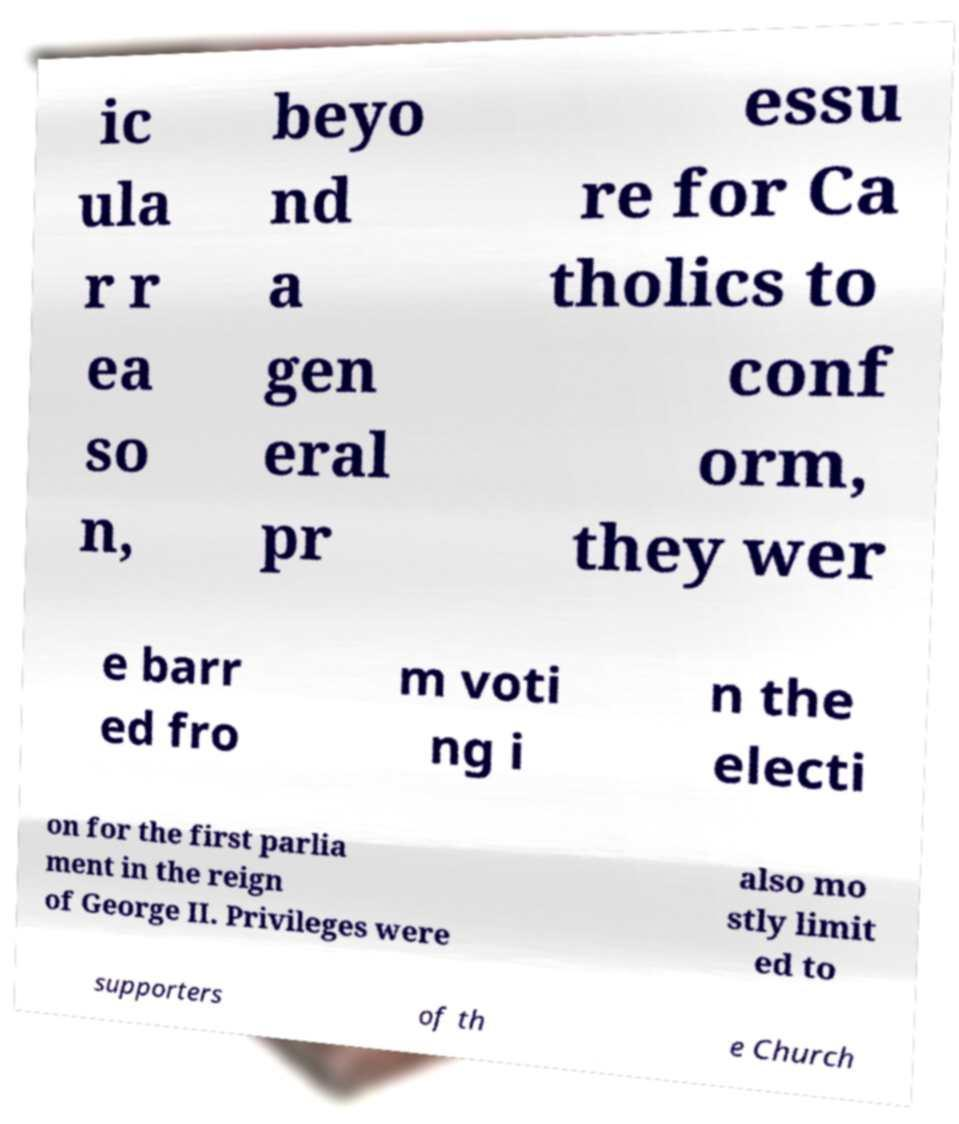Could you assist in decoding the text presented in this image and type it out clearly? ic ula r r ea so n, beyo nd a gen eral pr essu re for Ca tholics to conf orm, they wer e barr ed fro m voti ng i n the electi on for the first parlia ment in the reign of George II. Privileges were also mo stly limit ed to supporters of th e Church 